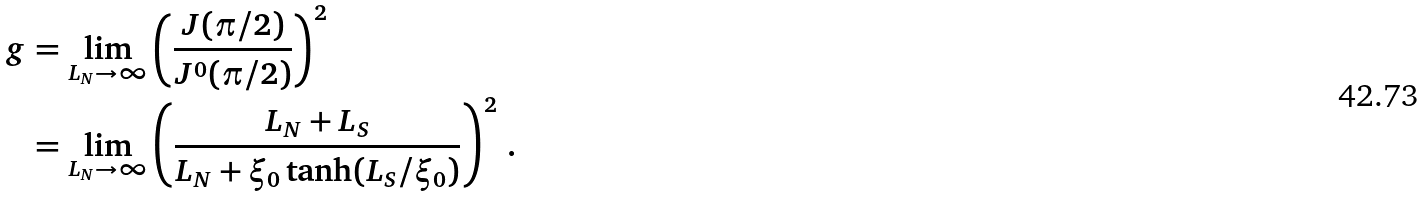<formula> <loc_0><loc_0><loc_500><loc_500>g & = \lim _ { L _ { N } \rightarrow \infty } \left ( \frac { J ( \pi / 2 ) } { J ^ { 0 } ( \pi / 2 ) } \right ) ^ { 2 } \\ & = \lim _ { L _ { N } \rightarrow \infty } \left ( \frac { L _ { N } + L _ { S } } { L _ { N } + \xi _ { 0 } \tanh ( L _ { S } / \xi _ { 0 } ) } \right ) ^ { 2 } \, .</formula> 